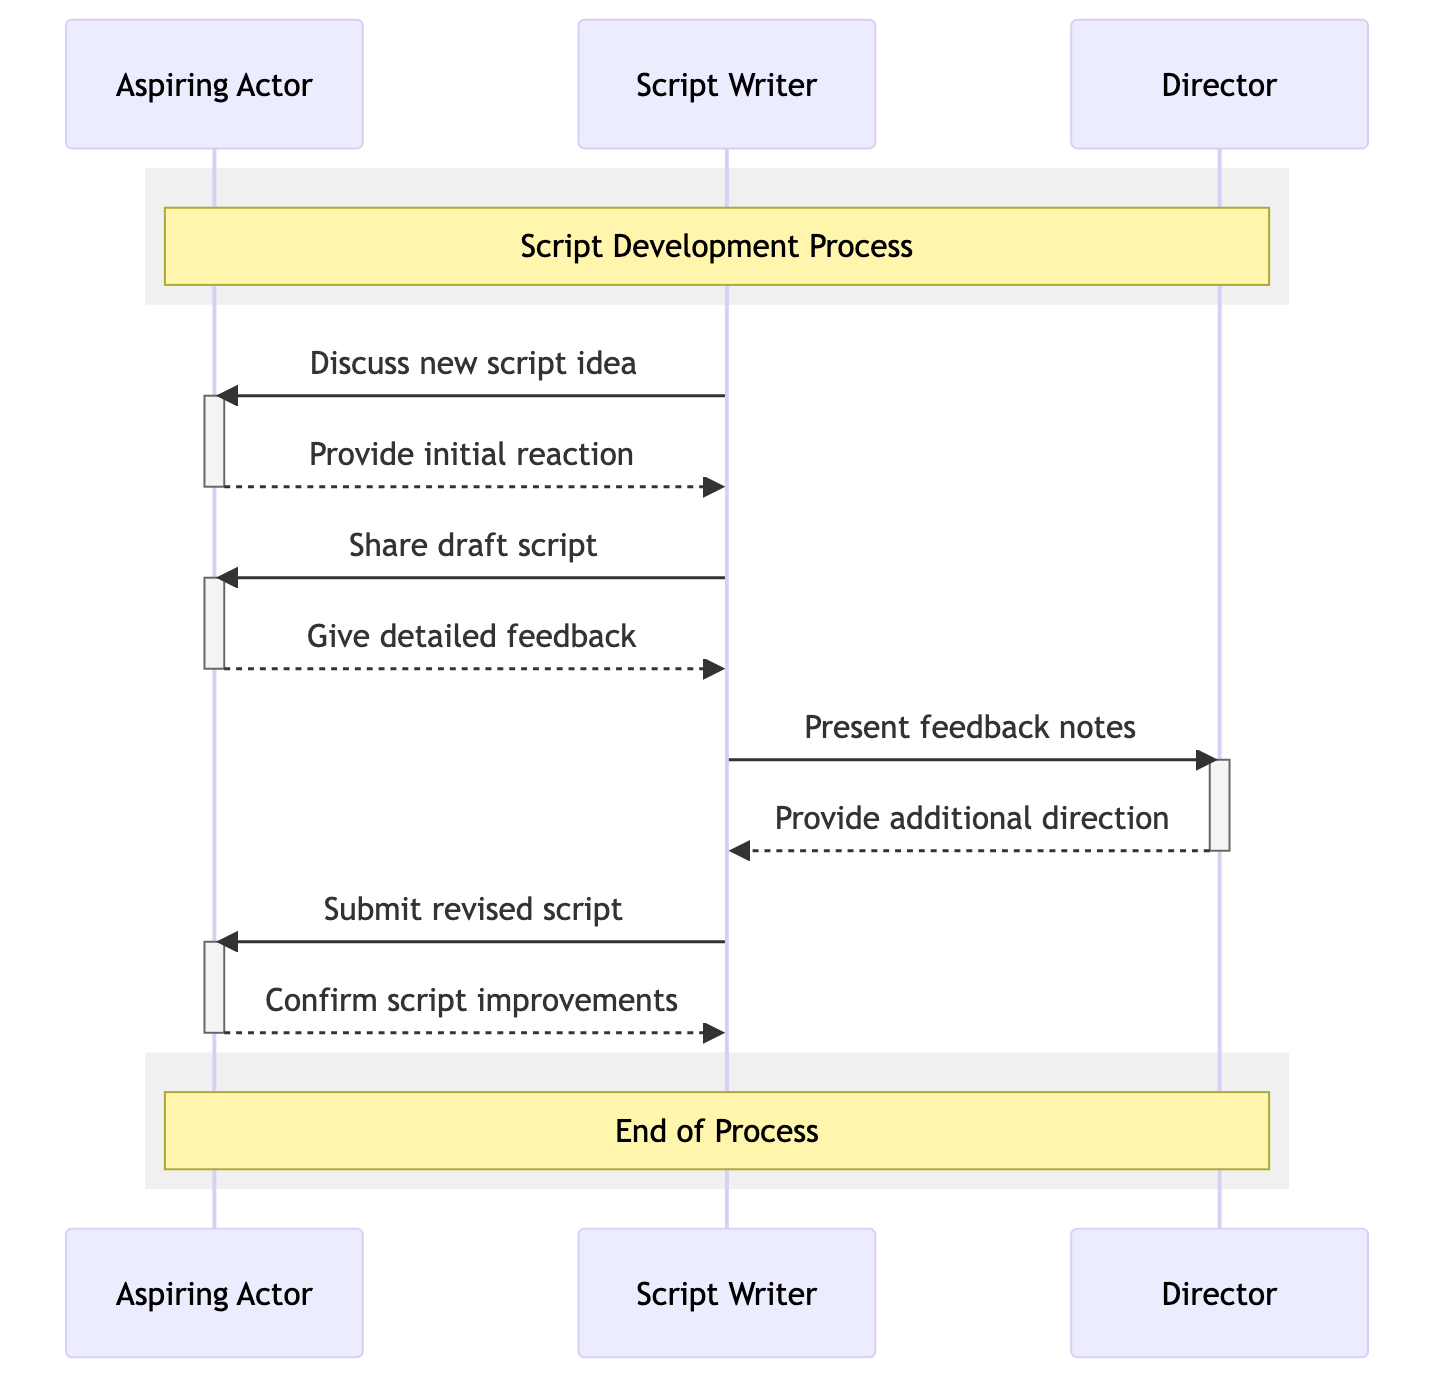What are the three actors involved in the diagram? The diagram features three actors representing the roles that communicate in the script feedback process. These actors are the Aspiring Actor, the Script Writer, and the Director.
Answer: Aspiring Actor, Script Writer, Director How many messages are exchanged in total? By counting each direct arrow (message) in the diagram, we can determine there are eight messages exchanged between the actors throughout the feedback process.
Answer: Eight Who initiates the discussion about the new script idea? The first message in the diagram shows that the Script Writer is the one who initiates the conversation about the new script idea as they send the message to the Aspiring Actor.
Answer: Script Writer What is the last message sent in the sequence? Analyzing the last arrow in the sequence diagram reveals that the last message sent is a confirmation of script improvements from the Aspiring Actor to the Script Writer.
Answer: Confirm script improvements Which actor receives additional direction after the feedback notes are presented? Following the presentation of the feedback notes by the Script Writer, it is the Director who responds with additional direction, as indicated by the message directed from the Director back to the Script Writer.
Answer: Director What is shared after the initial reaction is provided? After the Aspiring Actor gives the initial reaction, the next message indicates that the Script Writer shares the draft script with the Aspiring Actor, demonstrating the progress of feedback.
Answer: Draft script What type of feedback does the Aspiring Actor give? The Aspiring Actor engages in providing detailed feedback on the draft script as an essential part of the communication cycle, allowing the Script Writer to refine the script accordingly.
Answer: Detailed feedback How many times does the Script Writer interact with the Aspiring Actor? By analyzing the flow and count of the arrows between these two actors, we find that the Script Writer interacts with the Aspiring Actor a total of four times throughout the sequence.
Answer: Four times 